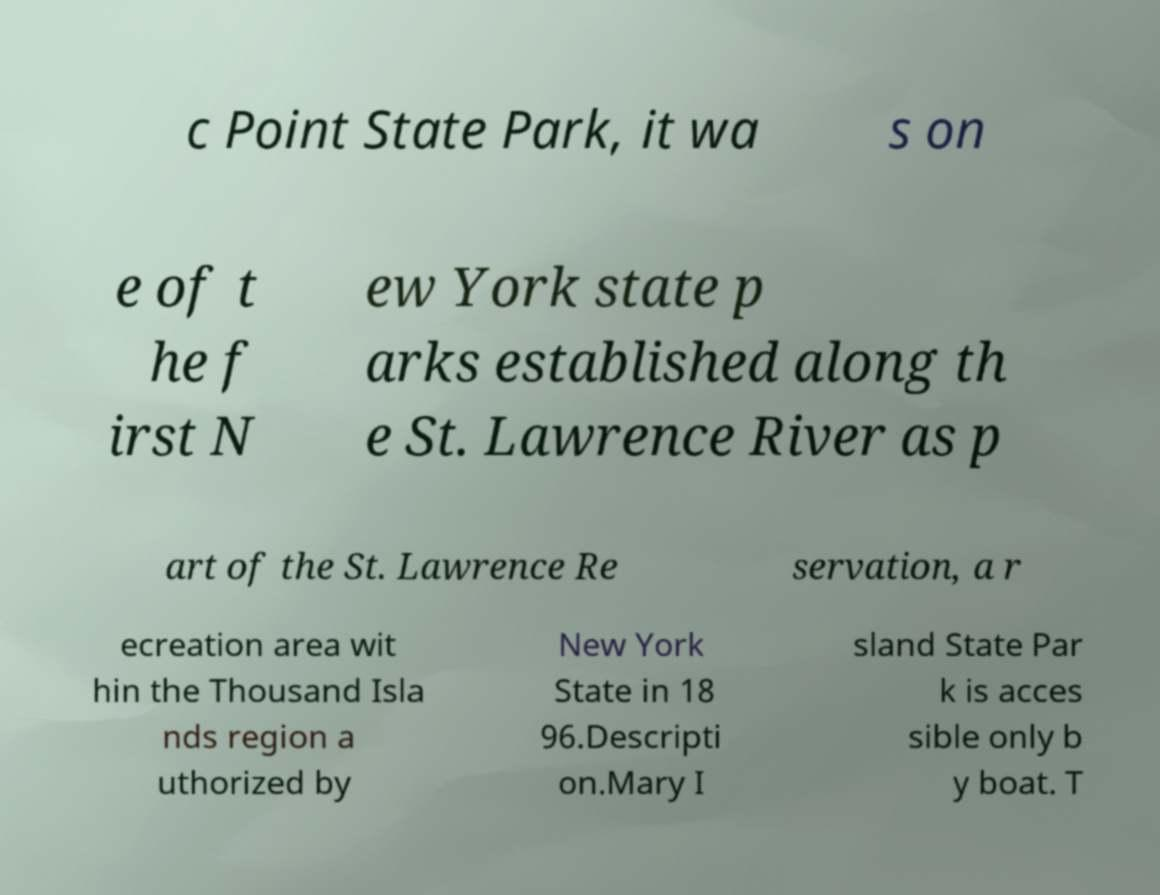Can you accurately transcribe the text from the provided image for me? c Point State Park, it wa s on e of t he f irst N ew York state p arks established along th e St. Lawrence River as p art of the St. Lawrence Re servation, a r ecreation area wit hin the Thousand Isla nds region a uthorized by New York State in 18 96.Descripti on.Mary I sland State Par k is acces sible only b y boat. T 